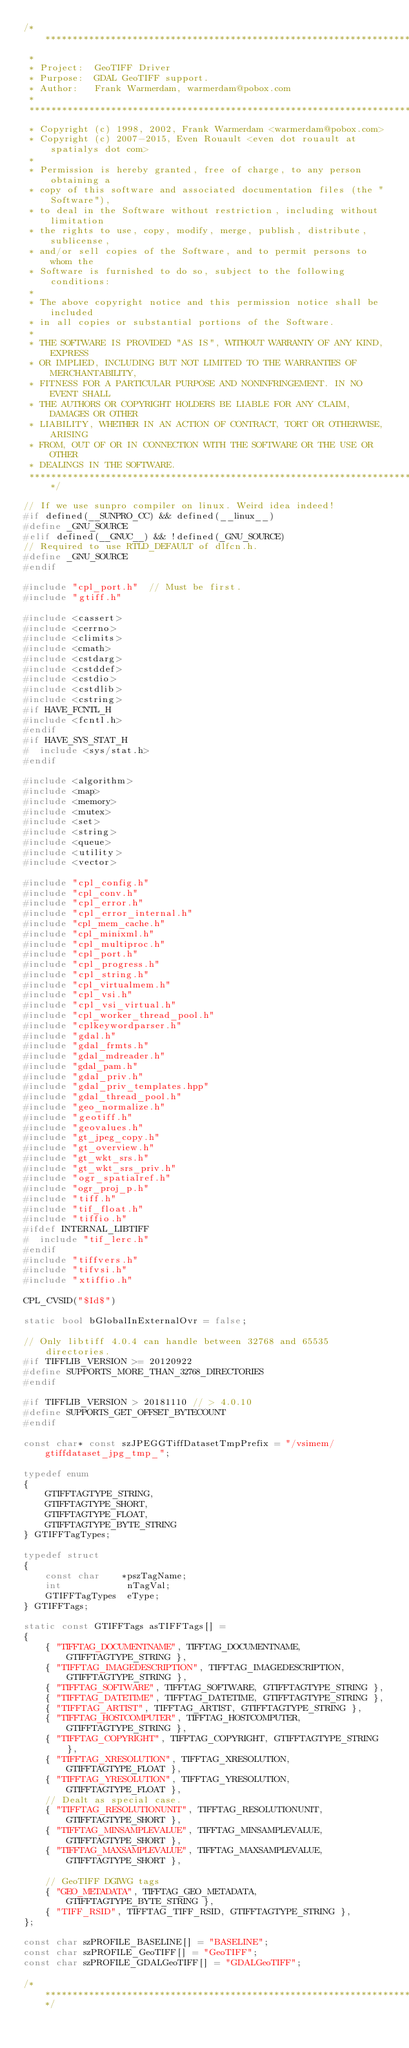<code> <loc_0><loc_0><loc_500><loc_500><_C++_>/******************************************************************************
 *
 * Project:  GeoTIFF Driver
 * Purpose:  GDAL GeoTIFF support.
 * Author:   Frank Warmerdam, warmerdam@pobox.com
 *
 ******************************************************************************
 * Copyright (c) 1998, 2002, Frank Warmerdam <warmerdam@pobox.com>
 * Copyright (c) 2007-2015, Even Rouault <even dot rouault at spatialys dot com>
 *
 * Permission is hereby granted, free of charge, to any person obtaining a
 * copy of this software and associated documentation files (the "Software"),
 * to deal in the Software without restriction, including without limitation
 * the rights to use, copy, modify, merge, publish, distribute, sublicense,
 * and/or sell copies of the Software, and to permit persons to whom the
 * Software is furnished to do so, subject to the following conditions:
 *
 * The above copyright notice and this permission notice shall be included
 * in all copies or substantial portions of the Software.
 *
 * THE SOFTWARE IS PROVIDED "AS IS", WITHOUT WARRANTY OF ANY KIND, EXPRESS
 * OR IMPLIED, INCLUDING BUT NOT LIMITED TO THE WARRANTIES OF MERCHANTABILITY,
 * FITNESS FOR A PARTICULAR PURPOSE AND NONINFRINGEMENT. IN NO EVENT SHALL
 * THE AUTHORS OR COPYRIGHT HOLDERS BE LIABLE FOR ANY CLAIM, DAMAGES OR OTHER
 * LIABILITY, WHETHER IN AN ACTION OF CONTRACT, TORT OR OTHERWISE, ARISING
 * FROM, OUT OF OR IN CONNECTION WITH THE SOFTWARE OR THE USE OR OTHER
 * DEALINGS IN THE SOFTWARE.
 ****************************************************************************/

// If we use sunpro compiler on linux. Weird idea indeed!
#if defined(__SUNPRO_CC) && defined(__linux__)
#define _GNU_SOURCE
#elif defined(__GNUC__) && !defined(_GNU_SOURCE)
// Required to use RTLD_DEFAULT of dlfcn.h.
#define _GNU_SOURCE
#endif

#include "cpl_port.h"  // Must be first.
#include "gtiff.h"

#include <cassert>
#include <cerrno>
#include <climits>
#include <cmath>
#include <cstdarg>
#include <cstddef>
#include <cstdio>
#include <cstdlib>
#include <cstring>
#if HAVE_FCNTL_H
#include <fcntl.h>
#endif
#if HAVE_SYS_STAT_H
#  include <sys/stat.h>
#endif

#include <algorithm>
#include <map>
#include <memory>
#include <mutex>
#include <set>
#include <string>
#include <queue>
#include <utility>
#include <vector>

#include "cpl_config.h"
#include "cpl_conv.h"
#include "cpl_error.h"
#include "cpl_error_internal.h"
#include "cpl_mem_cache.h"
#include "cpl_minixml.h"
#include "cpl_multiproc.h"
#include "cpl_port.h"
#include "cpl_progress.h"
#include "cpl_string.h"
#include "cpl_virtualmem.h"
#include "cpl_vsi.h"
#include "cpl_vsi_virtual.h"
#include "cpl_worker_thread_pool.h"
#include "cplkeywordparser.h"
#include "gdal.h"
#include "gdal_frmts.h"
#include "gdal_mdreader.h"
#include "gdal_pam.h"
#include "gdal_priv.h"
#include "gdal_priv_templates.hpp"
#include "gdal_thread_pool.h"
#include "geo_normalize.h"
#include "geotiff.h"
#include "geovalues.h"
#include "gt_jpeg_copy.h"
#include "gt_overview.h"
#include "gt_wkt_srs.h"
#include "gt_wkt_srs_priv.h"
#include "ogr_spatialref.h"
#include "ogr_proj_p.h"
#include "tiff.h"
#include "tif_float.h"
#include "tiffio.h"
#ifdef INTERNAL_LIBTIFF
#  include "tif_lerc.h"
#endif
#include "tiffvers.h"
#include "tifvsi.h"
#include "xtiffio.h"

CPL_CVSID("$Id$")

static bool bGlobalInExternalOvr = false;

// Only libtiff 4.0.4 can handle between 32768 and 65535 directories.
#if TIFFLIB_VERSION >= 20120922
#define SUPPORTS_MORE_THAN_32768_DIRECTORIES
#endif

#if TIFFLIB_VERSION > 20181110 // > 4.0.10
#define SUPPORTS_GET_OFFSET_BYTECOUNT
#endif

const char* const szJPEGGTiffDatasetTmpPrefix = "/vsimem/gtiffdataset_jpg_tmp_";

typedef enum
{
    GTIFFTAGTYPE_STRING,
    GTIFFTAGTYPE_SHORT,
    GTIFFTAGTYPE_FLOAT,
    GTIFFTAGTYPE_BYTE_STRING
} GTIFFTagTypes;

typedef struct
{
    const char    *pszTagName;
    int            nTagVal;
    GTIFFTagTypes  eType;
} GTIFFTags;

static const GTIFFTags asTIFFTags[] =
{
    { "TIFFTAG_DOCUMENTNAME", TIFFTAG_DOCUMENTNAME, GTIFFTAGTYPE_STRING },
    { "TIFFTAG_IMAGEDESCRIPTION", TIFFTAG_IMAGEDESCRIPTION,
        GTIFFTAGTYPE_STRING },
    { "TIFFTAG_SOFTWARE", TIFFTAG_SOFTWARE, GTIFFTAGTYPE_STRING },
    { "TIFFTAG_DATETIME", TIFFTAG_DATETIME, GTIFFTAGTYPE_STRING },
    { "TIFFTAG_ARTIST", TIFFTAG_ARTIST, GTIFFTAGTYPE_STRING },
    { "TIFFTAG_HOSTCOMPUTER", TIFFTAG_HOSTCOMPUTER, GTIFFTAGTYPE_STRING },
    { "TIFFTAG_COPYRIGHT", TIFFTAG_COPYRIGHT, GTIFFTAGTYPE_STRING },
    { "TIFFTAG_XRESOLUTION", TIFFTAG_XRESOLUTION, GTIFFTAGTYPE_FLOAT },
    { "TIFFTAG_YRESOLUTION", TIFFTAG_YRESOLUTION, GTIFFTAGTYPE_FLOAT },
    // Dealt as special case.
    { "TIFFTAG_RESOLUTIONUNIT", TIFFTAG_RESOLUTIONUNIT, GTIFFTAGTYPE_SHORT },
    { "TIFFTAG_MINSAMPLEVALUE", TIFFTAG_MINSAMPLEVALUE, GTIFFTAGTYPE_SHORT },
    { "TIFFTAG_MAXSAMPLEVALUE", TIFFTAG_MAXSAMPLEVALUE, GTIFFTAGTYPE_SHORT },

    // GeoTIFF DGIWG tags
    { "GEO_METADATA", TIFFTAG_GEO_METADATA, GTIFFTAGTYPE_BYTE_STRING },
    { "TIFF_RSID", TIFFTAG_TIFF_RSID, GTIFFTAGTYPE_STRING },
};

const char szPROFILE_BASELINE[] = "BASELINE";
const char szPROFILE_GeoTIFF[] = "GeoTIFF";
const char szPROFILE_GDALGeoTIFF[] = "GDALGeoTIFF";

/************************************************************************/</code> 